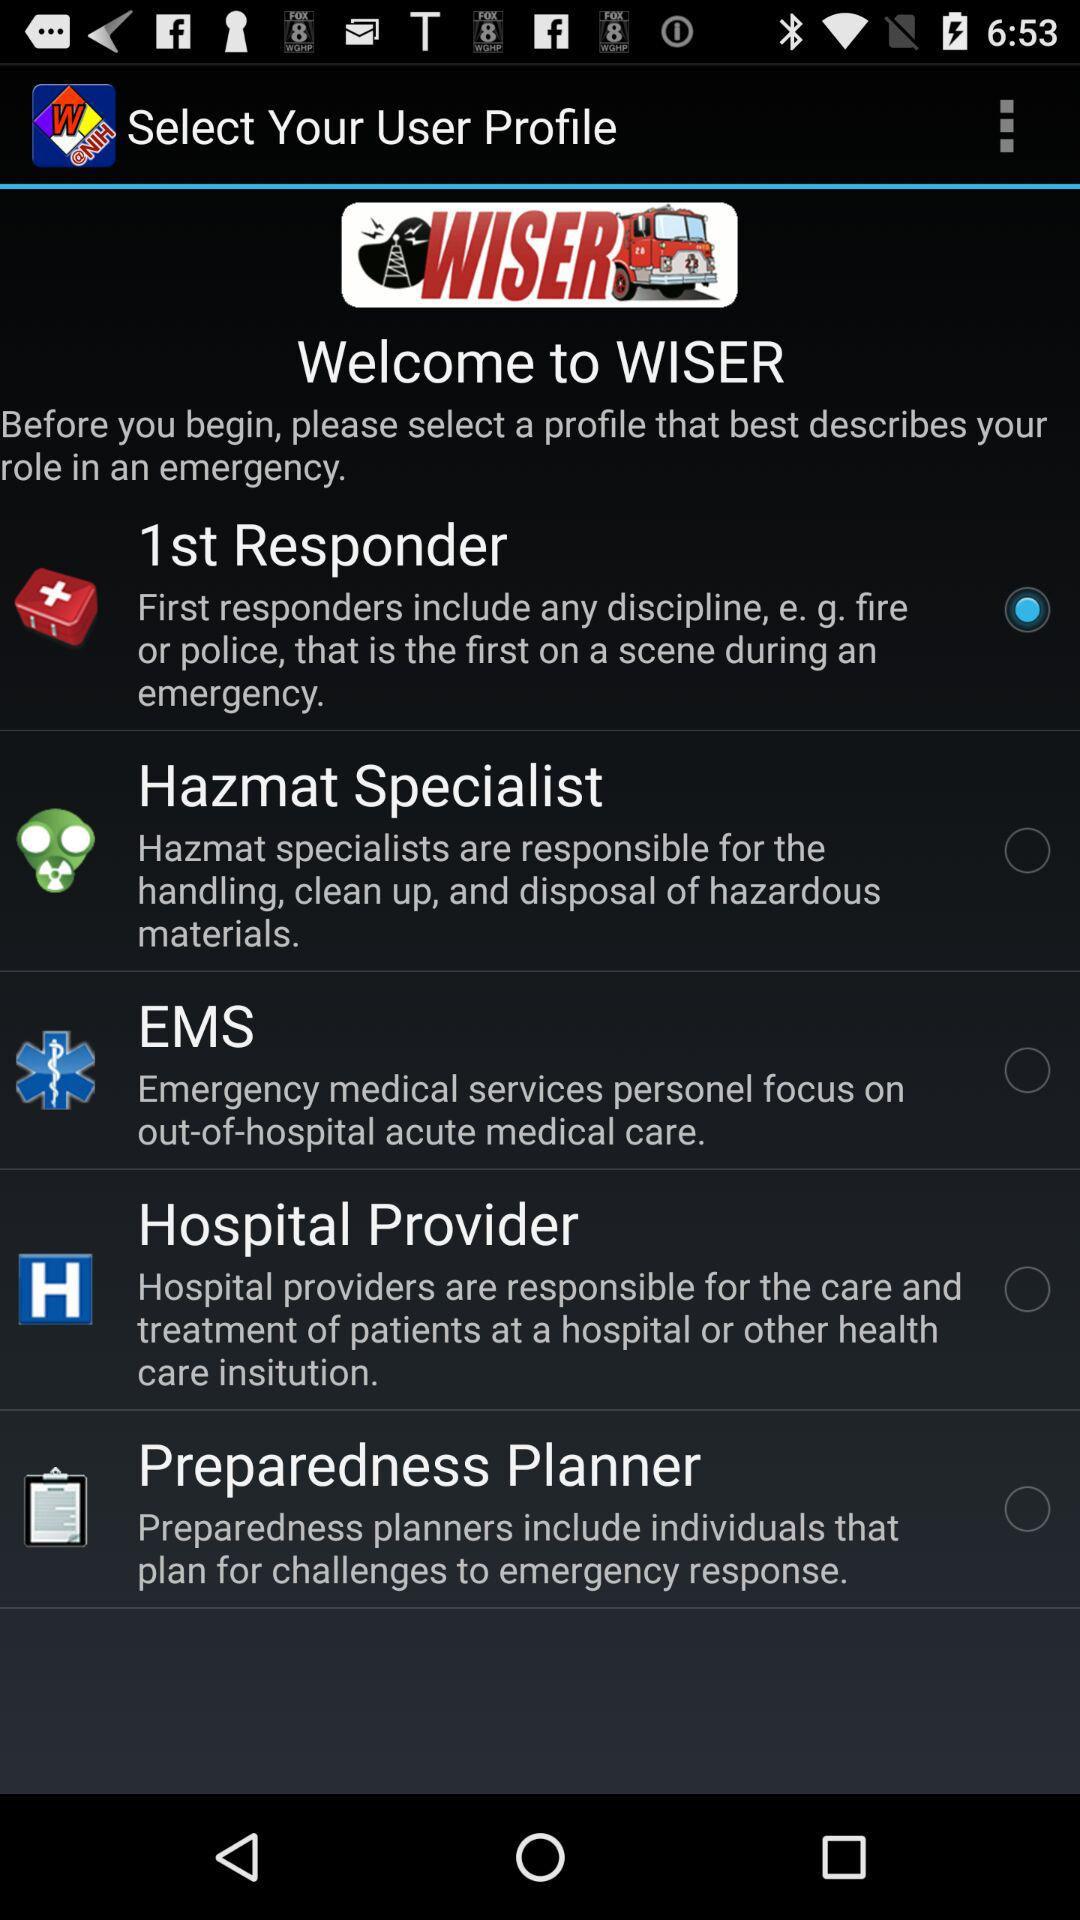How many different user profile types are there?
Answer the question using a single word or phrase. 5 